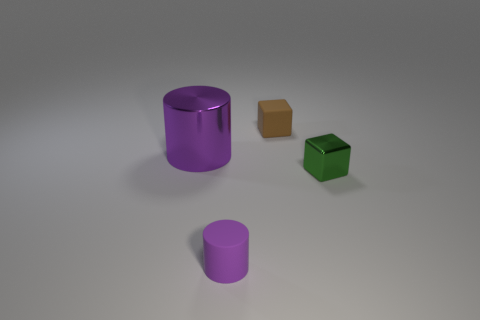Is there anything else that is made of the same material as the small brown thing?
Give a very brief answer. Yes. What number of large things are brown things or purple metal cylinders?
Offer a terse response. 1. There is a small matte thing in front of the tiny green metallic cube; is it the same shape as the brown thing?
Provide a succinct answer. No. Is the number of tiny purple balls less than the number of big purple cylinders?
Your answer should be compact. Yes. Is there any other thing that is the same color as the rubber cylinder?
Your answer should be compact. Yes. There is a small matte thing that is behind the purple matte cylinder; what shape is it?
Provide a short and direct response. Cube. There is a large metallic thing; is its color the same as the tiny matte thing in front of the metal cube?
Make the answer very short. Yes. Are there an equal number of shiny cylinders that are behind the brown block and tiny rubber cubes in front of the matte cylinder?
Your response must be concise. Yes. How many other things are there of the same size as the metal cube?
Provide a short and direct response. 2. What is the size of the purple rubber object?
Your answer should be very brief. Small. 